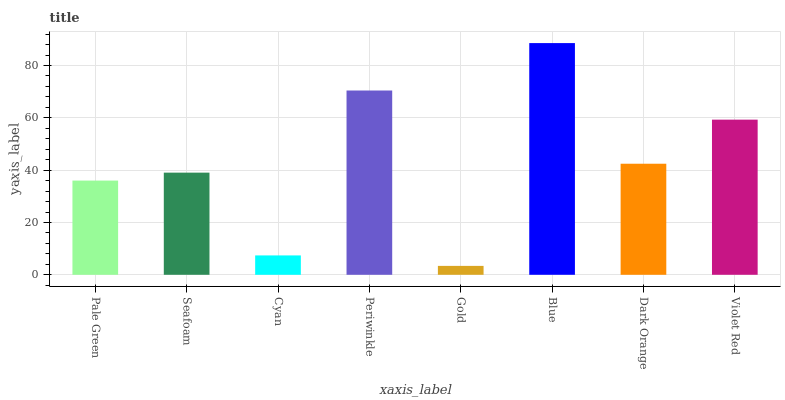Is Seafoam the minimum?
Answer yes or no. No. Is Seafoam the maximum?
Answer yes or no. No. Is Seafoam greater than Pale Green?
Answer yes or no. Yes. Is Pale Green less than Seafoam?
Answer yes or no. Yes. Is Pale Green greater than Seafoam?
Answer yes or no. No. Is Seafoam less than Pale Green?
Answer yes or no. No. Is Dark Orange the high median?
Answer yes or no. Yes. Is Seafoam the low median?
Answer yes or no. Yes. Is Violet Red the high median?
Answer yes or no. No. Is Periwinkle the low median?
Answer yes or no. No. 